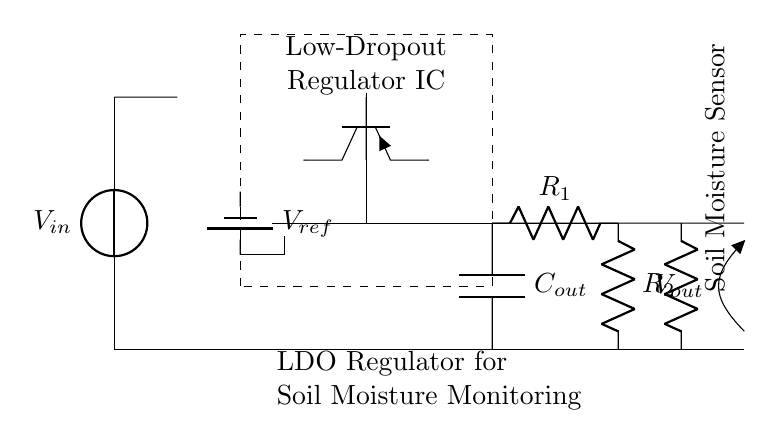What is the type of the regulator shown in the circuit? The circuit diagram depicts a low-dropout regulator, which is indicated by the label on the component.
Answer: low-dropout regulator What is the reference voltage represented in the circuit? The diagram shows a battery labeled as V_ref, which indicates the reference voltage used in the regulator.
Answer: V_ref How many resistors are present in the feedback network? The feedback network in the diagram contains two resistors, R1 and R2, between the output and the error amplifier.
Answer: 2 What component type is the soil moisture sensor? The load connected at the output is labeled as a soil moisture sensor, which indicates its type and function in the circuit.
Answer: resistor What is the function of the error amplifier in this circuit? The error amplifier compares the output voltage with the reference voltage and adjusts the pass transistor accordingly to maintain the desired output voltage. This is essential for stable operation.
Answer: regulate output voltage What is connected at the output of the low-dropout regulator? The output of the regulator is connected to the soil moisture sensor, which acts as the load requiring power from the regulator.
Answer: soil moisture sensor 